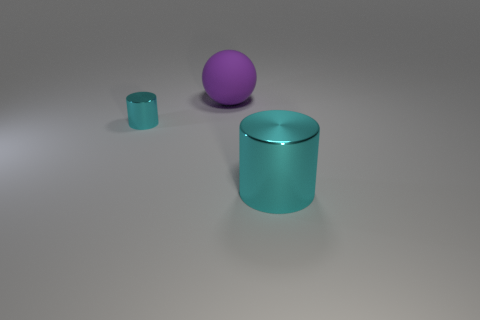What is the shape of the object in front of the cyan cylinder that is to the left of the object on the right side of the purple ball?
Ensure brevity in your answer.  Cylinder. Are there any large objects made of the same material as the big cylinder?
Your answer should be very brief. No. Is the color of the thing to the right of the large purple sphere the same as the big thing that is behind the tiny cyan cylinder?
Provide a short and direct response. No. Is the number of cylinders to the right of the purple object less than the number of small purple shiny objects?
Provide a succinct answer. No. How many things are either shiny cylinders or objects that are on the right side of the tiny cyan thing?
Ensure brevity in your answer.  3. There is another cylinder that is made of the same material as the big cylinder; what is its color?
Offer a very short reply. Cyan. How many things are either big cyan metal spheres or purple rubber balls?
Keep it short and to the point. 1. There is a shiny cylinder that is the same size as the purple ball; what is its color?
Ensure brevity in your answer.  Cyan. How many objects are metal cylinders behind the large metal cylinder or shiny cylinders?
Offer a very short reply. 2. How many other things are the same size as the matte object?
Your answer should be very brief. 1. 